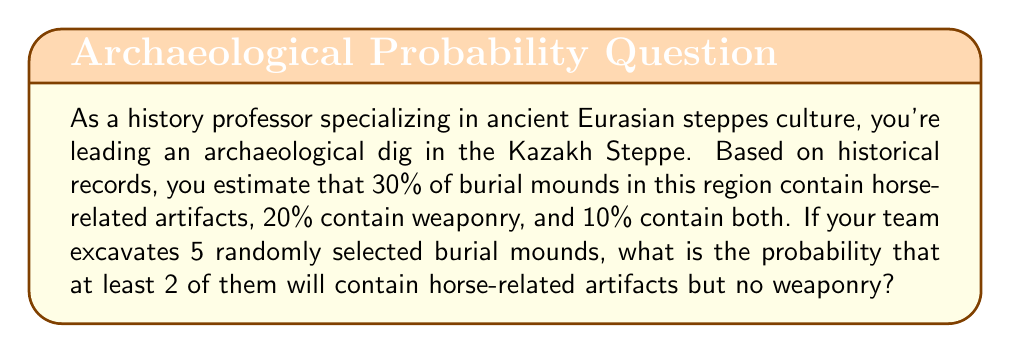Teach me how to tackle this problem. Let's approach this step-by-step:

1) First, we need to calculate the probability of finding a burial mound with horse-related artifacts but no weaponry.

   P(horse artifacts and no weaponry) = P(horse artifacts) - P(horse artifacts and weaponry)
   $$ P(H \text{ and not } W) = 0.30 - 0.10 = 0.20 $$

2) Now, we can treat this as a binomial probability problem. We want the probability of at least 2 successes in 5 trials, where success is defined as finding horse artifacts but no weaponry.

3) The probability of at least 2 successes is equal to 1 minus the probability of 0 or 1 success.

   $$ P(\text{at least 2}) = 1 - [P(0) + P(1)] $$

4) We can use the binomial probability formula:

   $$ P(X = k) = \binom{n}{k} p^k (1-p)^{n-k} $$

   Where $n = 5$ (number of mounds), $p = 0.20$ (probability of success), and $k$ is the number of successes.

5) Calculate P(0):

   $$ P(0) = \binom{5}{0} (0.20)^0 (0.80)^5 = 1 \cdot 1 \cdot 0.32768 = 0.32768 $$

6) Calculate P(1):

   $$ P(1) = \binom{5}{1} (0.20)^1 (0.80)^4 = 5 \cdot 0.20 \cdot 0.4096 = 0.4096 $$

7) Now we can complete our calculation:

   $$ P(\text{at least 2}) = 1 - [P(0) + P(1)] = 1 - (0.32768 + 0.4096) = 1 - 0.73728 = 0.26272 $$
Answer: The probability of finding at least 2 burial mounds with horse-related artifacts but no weaponry out of 5 randomly selected mounds is approximately 0.26272 or 26.27%. 